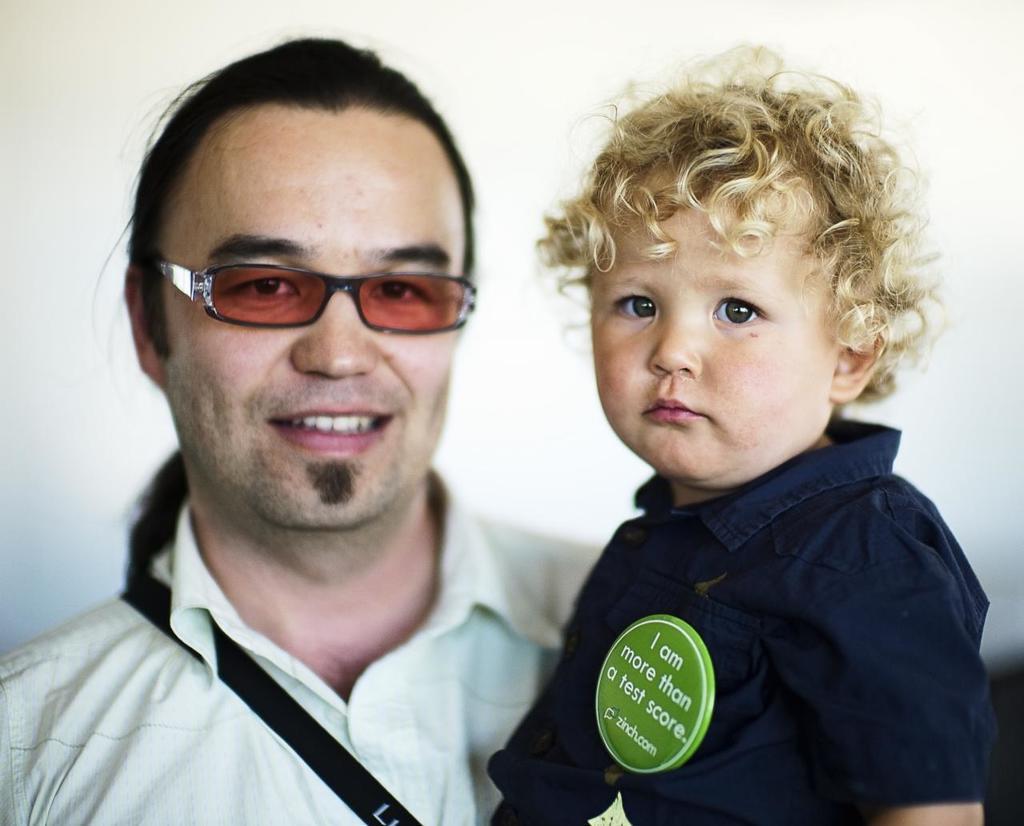Describe this image in one or two sentences. Here I can see a man wearing a shirt, carrying a baby and smiling. Both are looking at the picture. The background is in white color. There is a green color badge to the baby's dress. On the badge, I can see some text. 